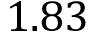Convert formula to latex. <formula><loc_0><loc_0><loc_500><loc_500>1 . 8 3</formula> 